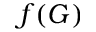<formula> <loc_0><loc_0><loc_500><loc_500>f ( G )</formula> 